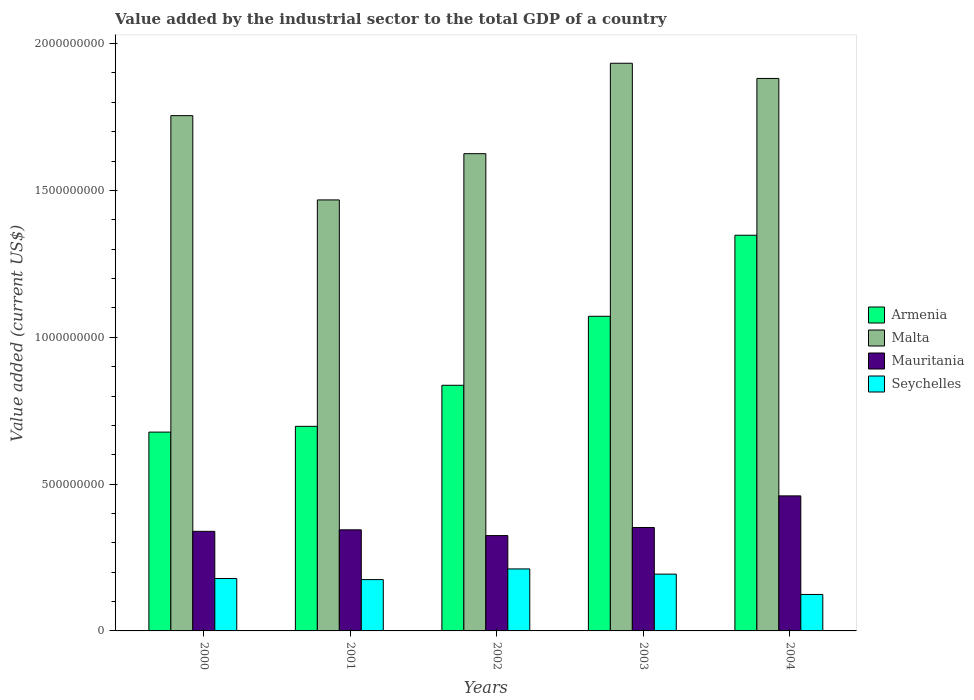How many groups of bars are there?
Your answer should be very brief. 5. Are the number of bars per tick equal to the number of legend labels?
Offer a very short reply. Yes. How many bars are there on the 1st tick from the left?
Your response must be concise. 4. In how many cases, is the number of bars for a given year not equal to the number of legend labels?
Give a very brief answer. 0. What is the value added by the industrial sector to the total GDP in Malta in 2003?
Your response must be concise. 1.93e+09. Across all years, what is the maximum value added by the industrial sector to the total GDP in Seychelles?
Keep it short and to the point. 2.11e+08. Across all years, what is the minimum value added by the industrial sector to the total GDP in Armenia?
Offer a terse response. 6.77e+08. In which year was the value added by the industrial sector to the total GDP in Mauritania minimum?
Provide a succinct answer. 2002. What is the total value added by the industrial sector to the total GDP in Seychelles in the graph?
Give a very brief answer. 8.82e+08. What is the difference between the value added by the industrial sector to the total GDP in Mauritania in 2000 and that in 2003?
Your answer should be very brief. -1.31e+07. What is the difference between the value added by the industrial sector to the total GDP in Mauritania in 2000 and the value added by the industrial sector to the total GDP in Malta in 2003?
Make the answer very short. -1.59e+09. What is the average value added by the industrial sector to the total GDP in Seychelles per year?
Provide a short and direct response. 1.76e+08. In the year 2000, what is the difference between the value added by the industrial sector to the total GDP in Seychelles and value added by the industrial sector to the total GDP in Armenia?
Your response must be concise. -4.99e+08. In how many years, is the value added by the industrial sector to the total GDP in Mauritania greater than 1700000000 US$?
Provide a succinct answer. 0. What is the ratio of the value added by the industrial sector to the total GDP in Malta in 2001 to that in 2002?
Your answer should be compact. 0.9. Is the value added by the industrial sector to the total GDP in Seychelles in 2000 less than that in 2003?
Give a very brief answer. Yes. What is the difference between the highest and the second highest value added by the industrial sector to the total GDP in Malta?
Your answer should be very brief. 5.17e+07. What is the difference between the highest and the lowest value added by the industrial sector to the total GDP in Seychelles?
Your answer should be very brief. 8.70e+07. Is it the case that in every year, the sum of the value added by the industrial sector to the total GDP in Malta and value added by the industrial sector to the total GDP in Armenia is greater than the sum of value added by the industrial sector to the total GDP in Mauritania and value added by the industrial sector to the total GDP in Seychelles?
Offer a very short reply. Yes. What does the 4th bar from the left in 2002 represents?
Your answer should be compact. Seychelles. What does the 2nd bar from the right in 2004 represents?
Offer a terse response. Mauritania. How many years are there in the graph?
Offer a terse response. 5. What is the difference between two consecutive major ticks on the Y-axis?
Your answer should be compact. 5.00e+08. Are the values on the major ticks of Y-axis written in scientific E-notation?
Provide a short and direct response. No. Does the graph contain any zero values?
Keep it short and to the point. No. Where does the legend appear in the graph?
Offer a terse response. Center right. How are the legend labels stacked?
Ensure brevity in your answer.  Vertical. What is the title of the graph?
Ensure brevity in your answer.  Value added by the industrial sector to the total GDP of a country. What is the label or title of the Y-axis?
Give a very brief answer. Value added (current US$). What is the Value added (current US$) in Armenia in 2000?
Keep it short and to the point. 6.77e+08. What is the Value added (current US$) in Malta in 2000?
Provide a succinct answer. 1.75e+09. What is the Value added (current US$) in Mauritania in 2000?
Keep it short and to the point. 3.39e+08. What is the Value added (current US$) of Seychelles in 2000?
Offer a terse response. 1.78e+08. What is the Value added (current US$) in Armenia in 2001?
Your response must be concise. 6.97e+08. What is the Value added (current US$) of Malta in 2001?
Offer a very short reply. 1.47e+09. What is the Value added (current US$) of Mauritania in 2001?
Offer a very short reply. 3.44e+08. What is the Value added (current US$) in Seychelles in 2001?
Make the answer very short. 1.75e+08. What is the Value added (current US$) of Armenia in 2002?
Offer a terse response. 8.37e+08. What is the Value added (current US$) in Malta in 2002?
Offer a terse response. 1.63e+09. What is the Value added (current US$) of Mauritania in 2002?
Make the answer very short. 3.25e+08. What is the Value added (current US$) of Seychelles in 2002?
Provide a succinct answer. 2.11e+08. What is the Value added (current US$) of Armenia in 2003?
Provide a succinct answer. 1.07e+09. What is the Value added (current US$) of Malta in 2003?
Offer a very short reply. 1.93e+09. What is the Value added (current US$) of Mauritania in 2003?
Provide a short and direct response. 3.52e+08. What is the Value added (current US$) of Seychelles in 2003?
Your response must be concise. 1.93e+08. What is the Value added (current US$) of Armenia in 2004?
Ensure brevity in your answer.  1.35e+09. What is the Value added (current US$) of Malta in 2004?
Offer a terse response. 1.88e+09. What is the Value added (current US$) of Mauritania in 2004?
Provide a succinct answer. 4.60e+08. What is the Value added (current US$) in Seychelles in 2004?
Offer a terse response. 1.24e+08. Across all years, what is the maximum Value added (current US$) of Armenia?
Give a very brief answer. 1.35e+09. Across all years, what is the maximum Value added (current US$) of Malta?
Provide a succinct answer. 1.93e+09. Across all years, what is the maximum Value added (current US$) of Mauritania?
Your response must be concise. 4.60e+08. Across all years, what is the maximum Value added (current US$) in Seychelles?
Your answer should be very brief. 2.11e+08. Across all years, what is the minimum Value added (current US$) in Armenia?
Provide a short and direct response. 6.77e+08. Across all years, what is the minimum Value added (current US$) of Malta?
Ensure brevity in your answer.  1.47e+09. Across all years, what is the minimum Value added (current US$) of Mauritania?
Your answer should be very brief. 3.25e+08. Across all years, what is the minimum Value added (current US$) of Seychelles?
Offer a very short reply. 1.24e+08. What is the total Value added (current US$) of Armenia in the graph?
Your answer should be very brief. 4.63e+09. What is the total Value added (current US$) in Malta in the graph?
Make the answer very short. 8.66e+09. What is the total Value added (current US$) of Mauritania in the graph?
Offer a very short reply. 1.82e+09. What is the total Value added (current US$) in Seychelles in the graph?
Ensure brevity in your answer.  8.82e+08. What is the difference between the Value added (current US$) of Armenia in 2000 and that in 2001?
Provide a short and direct response. -1.96e+07. What is the difference between the Value added (current US$) in Malta in 2000 and that in 2001?
Offer a terse response. 2.87e+08. What is the difference between the Value added (current US$) of Mauritania in 2000 and that in 2001?
Give a very brief answer. -5.12e+06. What is the difference between the Value added (current US$) of Seychelles in 2000 and that in 2001?
Keep it short and to the point. 3.66e+06. What is the difference between the Value added (current US$) in Armenia in 2000 and that in 2002?
Provide a succinct answer. -1.59e+08. What is the difference between the Value added (current US$) of Malta in 2000 and that in 2002?
Keep it short and to the point. 1.30e+08. What is the difference between the Value added (current US$) of Mauritania in 2000 and that in 2002?
Make the answer very short. 1.45e+07. What is the difference between the Value added (current US$) in Seychelles in 2000 and that in 2002?
Offer a terse response. -3.27e+07. What is the difference between the Value added (current US$) in Armenia in 2000 and that in 2003?
Make the answer very short. -3.94e+08. What is the difference between the Value added (current US$) in Malta in 2000 and that in 2003?
Give a very brief answer. -1.78e+08. What is the difference between the Value added (current US$) in Mauritania in 2000 and that in 2003?
Offer a very short reply. -1.31e+07. What is the difference between the Value added (current US$) in Seychelles in 2000 and that in 2003?
Offer a terse response. -1.50e+07. What is the difference between the Value added (current US$) in Armenia in 2000 and that in 2004?
Offer a terse response. -6.70e+08. What is the difference between the Value added (current US$) in Malta in 2000 and that in 2004?
Ensure brevity in your answer.  -1.27e+08. What is the difference between the Value added (current US$) in Mauritania in 2000 and that in 2004?
Offer a very short reply. -1.21e+08. What is the difference between the Value added (current US$) in Seychelles in 2000 and that in 2004?
Give a very brief answer. 5.43e+07. What is the difference between the Value added (current US$) in Armenia in 2001 and that in 2002?
Give a very brief answer. -1.40e+08. What is the difference between the Value added (current US$) of Malta in 2001 and that in 2002?
Give a very brief answer. -1.57e+08. What is the difference between the Value added (current US$) of Mauritania in 2001 and that in 2002?
Provide a short and direct response. 1.96e+07. What is the difference between the Value added (current US$) in Seychelles in 2001 and that in 2002?
Give a very brief answer. -3.63e+07. What is the difference between the Value added (current US$) of Armenia in 2001 and that in 2003?
Offer a terse response. -3.75e+08. What is the difference between the Value added (current US$) in Malta in 2001 and that in 2003?
Make the answer very short. -4.65e+08. What is the difference between the Value added (current US$) of Mauritania in 2001 and that in 2003?
Offer a very short reply. -7.99e+06. What is the difference between the Value added (current US$) in Seychelles in 2001 and that in 2003?
Give a very brief answer. -1.86e+07. What is the difference between the Value added (current US$) of Armenia in 2001 and that in 2004?
Your answer should be compact. -6.51e+08. What is the difference between the Value added (current US$) of Malta in 2001 and that in 2004?
Keep it short and to the point. -4.14e+08. What is the difference between the Value added (current US$) in Mauritania in 2001 and that in 2004?
Provide a succinct answer. -1.16e+08. What is the difference between the Value added (current US$) in Seychelles in 2001 and that in 2004?
Provide a succinct answer. 5.06e+07. What is the difference between the Value added (current US$) of Armenia in 2002 and that in 2003?
Give a very brief answer. -2.35e+08. What is the difference between the Value added (current US$) of Malta in 2002 and that in 2003?
Keep it short and to the point. -3.08e+08. What is the difference between the Value added (current US$) of Mauritania in 2002 and that in 2003?
Ensure brevity in your answer.  -2.76e+07. What is the difference between the Value added (current US$) of Seychelles in 2002 and that in 2003?
Ensure brevity in your answer.  1.77e+07. What is the difference between the Value added (current US$) of Armenia in 2002 and that in 2004?
Your answer should be compact. -5.11e+08. What is the difference between the Value added (current US$) in Malta in 2002 and that in 2004?
Give a very brief answer. -2.56e+08. What is the difference between the Value added (current US$) of Mauritania in 2002 and that in 2004?
Your answer should be compact. -1.35e+08. What is the difference between the Value added (current US$) of Seychelles in 2002 and that in 2004?
Your response must be concise. 8.70e+07. What is the difference between the Value added (current US$) in Armenia in 2003 and that in 2004?
Keep it short and to the point. -2.76e+08. What is the difference between the Value added (current US$) of Malta in 2003 and that in 2004?
Give a very brief answer. 5.17e+07. What is the difference between the Value added (current US$) of Mauritania in 2003 and that in 2004?
Make the answer very short. -1.08e+08. What is the difference between the Value added (current US$) in Seychelles in 2003 and that in 2004?
Your answer should be very brief. 6.92e+07. What is the difference between the Value added (current US$) of Armenia in 2000 and the Value added (current US$) of Malta in 2001?
Offer a terse response. -7.91e+08. What is the difference between the Value added (current US$) of Armenia in 2000 and the Value added (current US$) of Mauritania in 2001?
Offer a terse response. 3.33e+08. What is the difference between the Value added (current US$) of Armenia in 2000 and the Value added (current US$) of Seychelles in 2001?
Make the answer very short. 5.02e+08. What is the difference between the Value added (current US$) in Malta in 2000 and the Value added (current US$) in Mauritania in 2001?
Offer a very short reply. 1.41e+09. What is the difference between the Value added (current US$) of Malta in 2000 and the Value added (current US$) of Seychelles in 2001?
Your answer should be very brief. 1.58e+09. What is the difference between the Value added (current US$) of Mauritania in 2000 and the Value added (current US$) of Seychelles in 2001?
Your response must be concise. 1.64e+08. What is the difference between the Value added (current US$) in Armenia in 2000 and the Value added (current US$) in Malta in 2002?
Provide a succinct answer. -9.48e+08. What is the difference between the Value added (current US$) in Armenia in 2000 and the Value added (current US$) in Mauritania in 2002?
Provide a succinct answer. 3.52e+08. What is the difference between the Value added (current US$) in Armenia in 2000 and the Value added (current US$) in Seychelles in 2002?
Offer a very short reply. 4.66e+08. What is the difference between the Value added (current US$) in Malta in 2000 and the Value added (current US$) in Mauritania in 2002?
Offer a terse response. 1.43e+09. What is the difference between the Value added (current US$) in Malta in 2000 and the Value added (current US$) in Seychelles in 2002?
Offer a very short reply. 1.54e+09. What is the difference between the Value added (current US$) in Mauritania in 2000 and the Value added (current US$) in Seychelles in 2002?
Keep it short and to the point. 1.28e+08. What is the difference between the Value added (current US$) of Armenia in 2000 and the Value added (current US$) of Malta in 2003?
Your response must be concise. -1.26e+09. What is the difference between the Value added (current US$) of Armenia in 2000 and the Value added (current US$) of Mauritania in 2003?
Provide a short and direct response. 3.25e+08. What is the difference between the Value added (current US$) in Armenia in 2000 and the Value added (current US$) in Seychelles in 2003?
Provide a succinct answer. 4.84e+08. What is the difference between the Value added (current US$) of Malta in 2000 and the Value added (current US$) of Mauritania in 2003?
Your answer should be very brief. 1.40e+09. What is the difference between the Value added (current US$) in Malta in 2000 and the Value added (current US$) in Seychelles in 2003?
Offer a terse response. 1.56e+09. What is the difference between the Value added (current US$) in Mauritania in 2000 and the Value added (current US$) in Seychelles in 2003?
Offer a terse response. 1.46e+08. What is the difference between the Value added (current US$) in Armenia in 2000 and the Value added (current US$) in Malta in 2004?
Offer a very short reply. -1.20e+09. What is the difference between the Value added (current US$) in Armenia in 2000 and the Value added (current US$) in Mauritania in 2004?
Your answer should be compact. 2.17e+08. What is the difference between the Value added (current US$) in Armenia in 2000 and the Value added (current US$) in Seychelles in 2004?
Make the answer very short. 5.53e+08. What is the difference between the Value added (current US$) in Malta in 2000 and the Value added (current US$) in Mauritania in 2004?
Your answer should be very brief. 1.29e+09. What is the difference between the Value added (current US$) of Malta in 2000 and the Value added (current US$) of Seychelles in 2004?
Provide a short and direct response. 1.63e+09. What is the difference between the Value added (current US$) of Mauritania in 2000 and the Value added (current US$) of Seychelles in 2004?
Ensure brevity in your answer.  2.15e+08. What is the difference between the Value added (current US$) in Armenia in 2001 and the Value added (current US$) in Malta in 2002?
Keep it short and to the point. -9.29e+08. What is the difference between the Value added (current US$) in Armenia in 2001 and the Value added (current US$) in Mauritania in 2002?
Make the answer very short. 3.72e+08. What is the difference between the Value added (current US$) in Armenia in 2001 and the Value added (current US$) in Seychelles in 2002?
Ensure brevity in your answer.  4.86e+08. What is the difference between the Value added (current US$) in Malta in 2001 and the Value added (current US$) in Mauritania in 2002?
Your response must be concise. 1.14e+09. What is the difference between the Value added (current US$) of Malta in 2001 and the Value added (current US$) of Seychelles in 2002?
Ensure brevity in your answer.  1.26e+09. What is the difference between the Value added (current US$) in Mauritania in 2001 and the Value added (current US$) in Seychelles in 2002?
Keep it short and to the point. 1.33e+08. What is the difference between the Value added (current US$) of Armenia in 2001 and the Value added (current US$) of Malta in 2003?
Your response must be concise. -1.24e+09. What is the difference between the Value added (current US$) of Armenia in 2001 and the Value added (current US$) of Mauritania in 2003?
Keep it short and to the point. 3.44e+08. What is the difference between the Value added (current US$) in Armenia in 2001 and the Value added (current US$) in Seychelles in 2003?
Your answer should be very brief. 5.03e+08. What is the difference between the Value added (current US$) of Malta in 2001 and the Value added (current US$) of Mauritania in 2003?
Your response must be concise. 1.12e+09. What is the difference between the Value added (current US$) in Malta in 2001 and the Value added (current US$) in Seychelles in 2003?
Provide a short and direct response. 1.27e+09. What is the difference between the Value added (current US$) in Mauritania in 2001 and the Value added (current US$) in Seychelles in 2003?
Keep it short and to the point. 1.51e+08. What is the difference between the Value added (current US$) in Armenia in 2001 and the Value added (current US$) in Malta in 2004?
Provide a short and direct response. -1.18e+09. What is the difference between the Value added (current US$) in Armenia in 2001 and the Value added (current US$) in Mauritania in 2004?
Give a very brief answer. 2.37e+08. What is the difference between the Value added (current US$) in Armenia in 2001 and the Value added (current US$) in Seychelles in 2004?
Ensure brevity in your answer.  5.73e+08. What is the difference between the Value added (current US$) in Malta in 2001 and the Value added (current US$) in Mauritania in 2004?
Your answer should be very brief. 1.01e+09. What is the difference between the Value added (current US$) in Malta in 2001 and the Value added (current US$) in Seychelles in 2004?
Make the answer very short. 1.34e+09. What is the difference between the Value added (current US$) in Mauritania in 2001 and the Value added (current US$) in Seychelles in 2004?
Offer a very short reply. 2.20e+08. What is the difference between the Value added (current US$) of Armenia in 2002 and the Value added (current US$) of Malta in 2003?
Keep it short and to the point. -1.10e+09. What is the difference between the Value added (current US$) of Armenia in 2002 and the Value added (current US$) of Mauritania in 2003?
Your answer should be very brief. 4.84e+08. What is the difference between the Value added (current US$) of Armenia in 2002 and the Value added (current US$) of Seychelles in 2003?
Ensure brevity in your answer.  6.43e+08. What is the difference between the Value added (current US$) of Malta in 2002 and the Value added (current US$) of Mauritania in 2003?
Keep it short and to the point. 1.27e+09. What is the difference between the Value added (current US$) in Malta in 2002 and the Value added (current US$) in Seychelles in 2003?
Your answer should be compact. 1.43e+09. What is the difference between the Value added (current US$) of Mauritania in 2002 and the Value added (current US$) of Seychelles in 2003?
Your response must be concise. 1.31e+08. What is the difference between the Value added (current US$) of Armenia in 2002 and the Value added (current US$) of Malta in 2004?
Your response must be concise. -1.04e+09. What is the difference between the Value added (current US$) of Armenia in 2002 and the Value added (current US$) of Mauritania in 2004?
Make the answer very short. 3.77e+08. What is the difference between the Value added (current US$) in Armenia in 2002 and the Value added (current US$) in Seychelles in 2004?
Offer a very short reply. 7.12e+08. What is the difference between the Value added (current US$) in Malta in 2002 and the Value added (current US$) in Mauritania in 2004?
Provide a short and direct response. 1.17e+09. What is the difference between the Value added (current US$) of Malta in 2002 and the Value added (current US$) of Seychelles in 2004?
Offer a terse response. 1.50e+09. What is the difference between the Value added (current US$) in Mauritania in 2002 and the Value added (current US$) in Seychelles in 2004?
Keep it short and to the point. 2.01e+08. What is the difference between the Value added (current US$) in Armenia in 2003 and the Value added (current US$) in Malta in 2004?
Your response must be concise. -8.10e+08. What is the difference between the Value added (current US$) of Armenia in 2003 and the Value added (current US$) of Mauritania in 2004?
Ensure brevity in your answer.  6.12e+08. What is the difference between the Value added (current US$) of Armenia in 2003 and the Value added (current US$) of Seychelles in 2004?
Provide a short and direct response. 9.47e+08. What is the difference between the Value added (current US$) in Malta in 2003 and the Value added (current US$) in Mauritania in 2004?
Make the answer very short. 1.47e+09. What is the difference between the Value added (current US$) of Malta in 2003 and the Value added (current US$) of Seychelles in 2004?
Offer a very short reply. 1.81e+09. What is the difference between the Value added (current US$) in Mauritania in 2003 and the Value added (current US$) in Seychelles in 2004?
Offer a very short reply. 2.28e+08. What is the average Value added (current US$) of Armenia per year?
Provide a short and direct response. 9.26e+08. What is the average Value added (current US$) in Malta per year?
Your response must be concise. 1.73e+09. What is the average Value added (current US$) of Mauritania per year?
Offer a terse response. 3.64e+08. What is the average Value added (current US$) in Seychelles per year?
Provide a succinct answer. 1.76e+08. In the year 2000, what is the difference between the Value added (current US$) of Armenia and Value added (current US$) of Malta?
Your answer should be compact. -1.08e+09. In the year 2000, what is the difference between the Value added (current US$) in Armenia and Value added (current US$) in Mauritania?
Give a very brief answer. 3.38e+08. In the year 2000, what is the difference between the Value added (current US$) of Armenia and Value added (current US$) of Seychelles?
Your answer should be very brief. 4.99e+08. In the year 2000, what is the difference between the Value added (current US$) of Malta and Value added (current US$) of Mauritania?
Keep it short and to the point. 1.42e+09. In the year 2000, what is the difference between the Value added (current US$) in Malta and Value added (current US$) in Seychelles?
Offer a terse response. 1.58e+09. In the year 2000, what is the difference between the Value added (current US$) of Mauritania and Value added (current US$) of Seychelles?
Ensure brevity in your answer.  1.61e+08. In the year 2001, what is the difference between the Value added (current US$) in Armenia and Value added (current US$) in Malta?
Provide a succinct answer. -7.71e+08. In the year 2001, what is the difference between the Value added (current US$) in Armenia and Value added (current US$) in Mauritania?
Offer a terse response. 3.52e+08. In the year 2001, what is the difference between the Value added (current US$) of Armenia and Value added (current US$) of Seychelles?
Give a very brief answer. 5.22e+08. In the year 2001, what is the difference between the Value added (current US$) in Malta and Value added (current US$) in Mauritania?
Provide a short and direct response. 1.12e+09. In the year 2001, what is the difference between the Value added (current US$) in Malta and Value added (current US$) in Seychelles?
Keep it short and to the point. 1.29e+09. In the year 2001, what is the difference between the Value added (current US$) in Mauritania and Value added (current US$) in Seychelles?
Offer a very short reply. 1.69e+08. In the year 2002, what is the difference between the Value added (current US$) of Armenia and Value added (current US$) of Malta?
Your response must be concise. -7.89e+08. In the year 2002, what is the difference between the Value added (current US$) in Armenia and Value added (current US$) in Mauritania?
Offer a terse response. 5.12e+08. In the year 2002, what is the difference between the Value added (current US$) in Armenia and Value added (current US$) in Seychelles?
Your answer should be very brief. 6.25e+08. In the year 2002, what is the difference between the Value added (current US$) in Malta and Value added (current US$) in Mauritania?
Make the answer very short. 1.30e+09. In the year 2002, what is the difference between the Value added (current US$) of Malta and Value added (current US$) of Seychelles?
Provide a succinct answer. 1.41e+09. In the year 2002, what is the difference between the Value added (current US$) of Mauritania and Value added (current US$) of Seychelles?
Your answer should be compact. 1.14e+08. In the year 2003, what is the difference between the Value added (current US$) in Armenia and Value added (current US$) in Malta?
Offer a terse response. -8.62e+08. In the year 2003, what is the difference between the Value added (current US$) of Armenia and Value added (current US$) of Mauritania?
Your answer should be very brief. 7.19e+08. In the year 2003, what is the difference between the Value added (current US$) of Armenia and Value added (current US$) of Seychelles?
Make the answer very short. 8.78e+08. In the year 2003, what is the difference between the Value added (current US$) of Malta and Value added (current US$) of Mauritania?
Provide a short and direct response. 1.58e+09. In the year 2003, what is the difference between the Value added (current US$) in Malta and Value added (current US$) in Seychelles?
Give a very brief answer. 1.74e+09. In the year 2003, what is the difference between the Value added (current US$) in Mauritania and Value added (current US$) in Seychelles?
Your response must be concise. 1.59e+08. In the year 2004, what is the difference between the Value added (current US$) in Armenia and Value added (current US$) in Malta?
Offer a very short reply. -5.34e+08. In the year 2004, what is the difference between the Value added (current US$) in Armenia and Value added (current US$) in Mauritania?
Provide a succinct answer. 8.88e+08. In the year 2004, what is the difference between the Value added (current US$) in Armenia and Value added (current US$) in Seychelles?
Your answer should be compact. 1.22e+09. In the year 2004, what is the difference between the Value added (current US$) of Malta and Value added (current US$) of Mauritania?
Provide a short and direct response. 1.42e+09. In the year 2004, what is the difference between the Value added (current US$) of Malta and Value added (current US$) of Seychelles?
Keep it short and to the point. 1.76e+09. In the year 2004, what is the difference between the Value added (current US$) of Mauritania and Value added (current US$) of Seychelles?
Give a very brief answer. 3.36e+08. What is the ratio of the Value added (current US$) in Armenia in 2000 to that in 2001?
Ensure brevity in your answer.  0.97. What is the ratio of the Value added (current US$) in Malta in 2000 to that in 2001?
Offer a very short reply. 1.2. What is the ratio of the Value added (current US$) in Mauritania in 2000 to that in 2001?
Your answer should be compact. 0.99. What is the ratio of the Value added (current US$) in Seychelles in 2000 to that in 2001?
Keep it short and to the point. 1.02. What is the ratio of the Value added (current US$) of Armenia in 2000 to that in 2002?
Provide a succinct answer. 0.81. What is the ratio of the Value added (current US$) of Malta in 2000 to that in 2002?
Your answer should be very brief. 1.08. What is the ratio of the Value added (current US$) of Mauritania in 2000 to that in 2002?
Your response must be concise. 1.04. What is the ratio of the Value added (current US$) in Seychelles in 2000 to that in 2002?
Offer a very short reply. 0.85. What is the ratio of the Value added (current US$) of Armenia in 2000 to that in 2003?
Your answer should be compact. 0.63. What is the ratio of the Value added (current US$) of Malta in 2000 to that in 2003?
Give a very brief answer. 0.91. What is the ratio of the Value added (current US$) of Mauritania in 2000 to that in 2003?
Offer a terse response. 0.96. What is the ratio of the Value added (current US$) in Seychelles in 2000 to that in 2003?
Keep it short and to the point. 0.92. What is the ratio of the Value added (current US$) in Armenia in 2000 to that in 2004?
Keep it short and to the point. 0.5. What is the ratio of the Value added (current US$) in Malta in 2000 to that in 2004?
Keep it short and to the point. 0.93. What is the ratio of the Value added (current US$) in Mauritania in 2000 to that in 2004?
Provide a succinct answer. 0.74. What is the ratio of the Value added (current US$) in Seychelles in 2000 to that in 2004?
Your response must be concise. 1.44. What is the ratio of the Value added (current US$) of Armenia in 2001 to that in 2002?
Your answer should be compact. 0.83. What is the ratio of the Value added (current US$) in Malta in 2001 to that in 2002?
Keep it short and to the point. 0.9. What is the ratio of the Value added (current US$) in Mauritania in 2001 to that in 2002?
Provide a short and direct response. 1.06. What is the ratio of the Value added (current US$) in Seychelles in 2001 to that in 2002?
Offer a terse response. 0.83. What is the ratio of the Value added (current US$) of Armenia in 2001 to that in 2003?
Keep it short and to the point. 0.65. What is the ratio of the Value added (current US$) in Malta in 2001 to that in 2003?
Your answer should be very brief. 0.76. What is the ratio of the Value added (current US$) of Mauritania in 2001 to that in 2003?
Offer a terse response. 0.98. What is the ratio of the Value added (current US$) of Seychelles in 2001 to that in 2003?
Offer a very short reply. 0.9. What is the ratio of the Value added (current US$) in Armenia in 2001 to that in 2004?
Your answer should be compact. 0.52. What is the ratio of the Value added (current US$) in Malta in 2001 to that in 2004?
Your response must be concise. 0.78. What is the ratio of the Value added (current US$) of Mauritania in 2001 to that in 2004?
Offer a very short reply. 0.75. What is the ratio of the Value added (current US$) of Seychelles in 2001 to that in 2004?
Provide a short and direct response. 1.41. What is the ratio of the Value added (current US$) in Armenia in 2002 to that in 2003?
Ensure brevity in your answer.  0.78. What is the ratio of the Value added (current US$) in Malta in 2002 to that in 2003?
Offer a terse response. 0.84. What is the ratio of the Value added (current US$) of Mauritania in 2002 to that in 2003?
Make the answer very short. 0.92. What is the ratio of the Value added (current US$) of Seychelles in 2002 to that in 2003?
Your answer should be compact. 1.09. What is the ratio of the Value added (current US$) in Armenia in 2002 to that in 2004?
Your answer should be very brief. 0.62. What is the ratio of the Value added (current US$) in Malta in 2002 to that in 2004?
Make the answer very short. 0.86. What is the ratio of the Value added (current US$) in Mauritania in 2002 to that in 2004?
Ensure brevity in your answer.  0.71. What is the ratio of the Value added (current US$) of Seychelles in 2002 to that in 2004?
Make the answer very short. 1.7. What is the ratio of the Value added (current US$) of Armenia in 2003 to that in 2004?
Offer a terse response. 0.8. What is the ratio of the Value added (current US$) in Malta in 2003 to that in 2004?
Your answer should be very brief. 1.03. What is the ratio of the Value added (current US$) of Mauritania in 2003 to that in 2004?
Offer a very short reply. 0.77. What is the ratio of the Value added (current US$) of Seychelles in 2003 to that in 2004?
Offer a very short reply. 1.56. What is the difference between the highest and the second highest Value added (current US$) of Armenia?
Your answer should be compact. 2.76e+08. What is the difference between the highest and the second highest Value added (current US$) in Malta?
Your response must be concise. 5.17e+07. What is the difference between the highest and the second highest Value added (current US$) of Mauritania?
Provide a short and direct response. 1.08e+08. What is the difference between the highest and the second highest Value added (current US$) of Seychelles?
Your answer should be very brief. 1.77e+07. What is the difference between the highest and the lowest Value added (current US$) in Armenia?
Make the answer very short. 6.70e+08. What is the difference between the highest and the lowest Value added (current US$) of Malta?
Offer a terse response. 4.65e+08. What is the difference between the highest and the lowest Value added (current US$) in Mauritania?
Make the answer very short. 1.35e+08. What is the difference between the highest and the lowest Value added (current US$) of Seychelles?
Make the answer very short. 8.70e+07. 